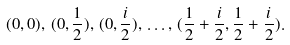Convert formula to latex. <formula><loc_0><loc_0><loc_500><loc_500>( 0 , 0 ) , \, ( 0 , \frac { 1 } { 2 } ) , \, ( 0 , \frac { i } { 2 } ) , \, \dots , \, ( \frac { 1 } { 2 } + \frac { i } { 2 } , \frac { 1 } { 2 } + \frac { i } { 2 } ) .</formula> 